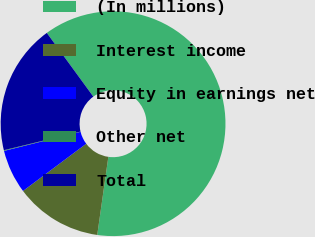Convert chart to OTSL. <chart><loc_0><loc_0><loc_500><loc_500><pie_chart><fcel>(In millions)<fcel>Interest income<fcel>Equity in earnings net<fcel>Other net<fcel>Total<nl><fcel>62.29%<fcel>12.54%<fcel>6.32%<fcel>0.1%<fcel>18.76%<nl></chart> 